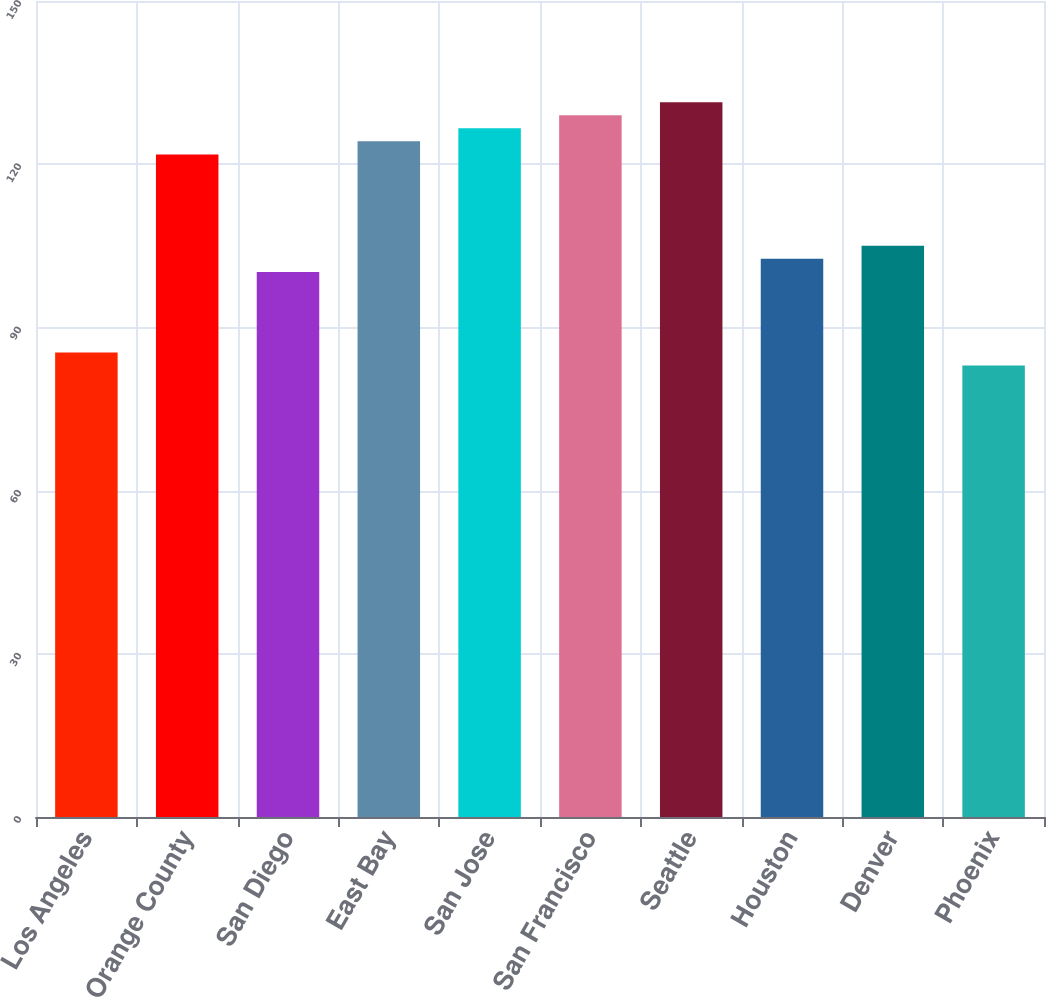Convert chart to OTSL. <chart><loc_0><loc_0><loc_500><loc_500><bar_chart><fcel>Los Angeles<fcel>Orange County<fcel>San Diego<fcel>East Bay<fcel>San Jose<fcel>San Francisco<fcel>Seattle<fcel>Houston<fcel>Denver<fcel>Phoenix<nl><fcel>85.4<fcel>121.8<fcel>100.2<fcel>124.2<fcel>126.6<fcel>129<fcel>131.4<fcel>102.6<fcel>105<fcel>83<nl></chart> 